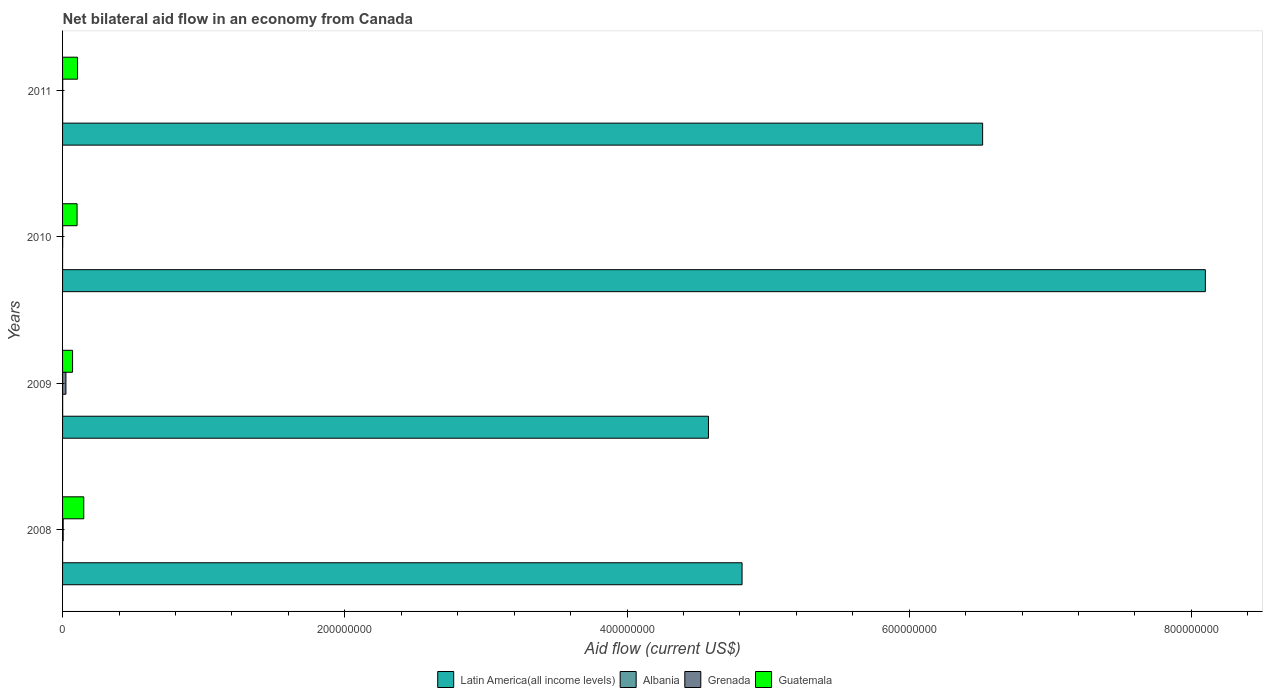How many different coloured bars are there?
Ensure brevity in your answer.  4. How many groups of bars are there?
Your answer should be compact. 4. Are the number of bars per tick equal to the number of legend labels?
Offer a very short reply. Yes. How many bars are there on the 1st tick from the top?
Your answer should be compact. 4. What is the label of the 3rd group of bars from the top?
Offer a terse response. 2009. Across all years, what is the maximum net bilateral aid flow in Grenada?
Ensure brevity in your answer.  2.38e+06. Across all years, what is the minimum net bilateral aid flow in Grenada?
Give a very brief answer. 9.00e+04. In which year was the net bilateral aid flow in Guatemala minimum?
Your answer should be compact. 2009. What is the total net bilateral aid flow in Guatemala in the graph?
Your answer should be compact. 4.30e+07. What is the difference between the net bilateral aid flow in Latin America(all income levels) in 2010 and the net bilateral aid flow in Grenada in 2009?
Your answer should be very brief. 8.07e+08. What is the average net bilateral aid flow in Albania per year?
Offer a very short reply. 4.50e+04. In the year 2011, what is the difference between the net bilateral aid flow in Albania and net bilateral aid flow in Guatemala?
Your response must be concise. -1.05e+07. What is the ratio of the net bilateral aid flow in Latin America(all income levels) in 2008 to that in 2011?
Keep it short and to the point. 0.74. Is the net bilateral aid flow in Latin America(all income levels) in 2009 less than that in 2011?
Provide a succinct answer. Yes. What is the difference between the highest and the second highest net bilateral aid flow in Albania?
Provide a short and direct response. 10000. What is the difference between the highest and the lowest net bilateral aid flow in Latin America(all income levels)?
Your response must be concise. 3.52e+08. In how many years, is the net bilateral aid flow in Guatemala greater than the average net bilateral aid flow in Guatemala taken over all years?
Offer a terse response. 1. Is the sum of the net bilateral aid flow in Albania in 2009 and 2010 greater than the maximum net bilateral aid flow in Latin America(all income levels) across all years?
Provide a succinct answer. No. Is it the case that in every year, the sum of the net bilateral aid flow in Grenada and net bilateral aid flow in Albania is greater than the sum of net bilateral aid flow in Guatemala and net bilateral aid flow in Latin America(all income levels)?
Your response must be concise. No. What does the 4th bar from the top in 2008 represents?
Make the answer very short. Latin America(all income levels). What does the 2nd bar from the bottom in 2011 represents?
Offer a very short reply. Albania. Is it the case that in every year, the sum of the net bilateral aid flow in Latin America(all income levels) and net bilateral aid flow in Albania is greater than the net bilateral aid flow in Grenada?
Ensure brevity in your answer.  Yes. How many bars are there?
Keep it short and to the point. 16. How many years are there in the graph?
Offer a very short reply. 4. What is the difference between two consecutive major ticks on the X-axis?
Your response must be concise. 2.00e+08. Are the values on the major ticks of X-axis written in scientific E-notation?
Keep it short and to the point. No. Does the graph contain any zero values?
Provide a succinct answer. No. Does the graph contain grids?
Ensure brevity in your answer.  No. Where does the legend appear in the graph?
Your response must be concise. Bottom center. How are the legend labels stacked?
Offer a very short reply. Horizontal. What is the title of the graph?
Give a very brief answer. Net bilateral aid flow in an economy from Canada. Does "Grenada" appear as one of the legend labels in the graph?
Keep it short and to the point. Yes. What is the label or title of the Y-axis?
Give a very brief answer. Years. What is the Aid flow (current US$) in Latin America(all income levels) in 2008?
Ensure brevity in your answer.  4.82e+08. What is the Aid flow (current US$) of Grenada in 2008?
Provide a succinct answer. 4.40e+05. What is the Aid flow (current US$) in Guatemala in 2008?
Provide a short and direct response. 1.50e+07. What is the Aid flow (current US$) in Latin America(all income levels) in 2009?
Make the answer very short. 4.58e+08. What is the Aid flow (current US$) of Grenada in 2009?
Ensure brevity in your answer.  2.38e+06. What is the Aid flow (current US$) in Guatemala in 2009?
Your answer should be very brief. 7.08e+06. What is the Aid flow (current US$) of Latin America(all income levels) in 2010?
Keep it short and to the point. 8.10e+08. What is the Aid flow (current US$) in Guatemala in 2010?
Provide a short and direct response. 1.03e+07. What is the Aid flow (current US$) of Latin America(all income levels) in 2011?
Provide a short and direct response. 6.52e+08. What is the Aid flow (current US$) in Albania in 2011?
Ensure brevity in your answer.  7.00e+04. What is the Aid flow (current US$) of Guatemala in 2011?
Your answer should be compact. 1.06e+07. Across all years, what is the maximum Aid flow (current US$) in Latin America(all income levels)?
Keep it short and to the point. 8.10e+08. Across all years, what is the maximum Aid flow (current US$) in Albania?
Make the answer very short. 7.00e+04. Across all years, what is the maximum Aid flow (current US$) in Grenada?
Keep it short and to the point. 2.38e+06. Across all years, what is the maximum Aid flow (current US$) in Guatemala?
Ensure brevity in your answer.  1.50e+07. Across all years, what is the minimum Aid flow (current US$) of Latin America(all income levels)?
Offer a terse response. 4.58e+08. Across all years, what is the minimum Aid flow (current US$) of Grenada?
Your response must be concise. 9.00e+04. Across all years, what is the minimum Aid flow (current US$) of Guatemala?
Keep it short and to the point. 7.08e+06. What is the total Aid flow (current US$) in Latin America(all income levels) in the graph?
Offer a terse response. 2.40e+09. What is the total Aid flow (current US$) of Grenada in the graph?
Offer a terse response. 3.02e+06. What is the total Aid flow (current US$) in Guatemala in the graph?
Your response must be concise. 4.30e+07. What is the difference between the Aid flow (current US$) in Latin America(all income levels) in 2008 and that in 2009?
Provide a succinct answer. 2.38e+07. What is the difference between the Aid flow (current US$) in Grenada in 2008 and that in 2009?
Ensure brevity in your answer.  -1.94e+06. What is the difference between the Aid flow (current US$) in Guatemala in 2008 and that in 2009?
Your response must be concise. 7.94e+06. What is the difference between the Aid flow (current US$) in Latin America(all income levels) in 2008 and that in 2010?
Give a very brief answer. -3.28e+08. What is the difference between the Aid flow (current US$) in Grenada in 2008 and that in 2010?
Give a very brief answer. 3.50e+05. What is the difference between the Aid flow (current US$) in Guatemala in 2008 and that in 2010?
Your answer should be very brief. 4.75e+06. What is the difference between the Aid flow (current US$) of Latin America(all income levels) in 2008 and that in 2011?
Provide a succinct answer. -1.70e+08. What is the difference between the Aid flow (current US$) in Grenada in 2008 and that in 2011?
Give a very brief answer. 3.30e+05. What is the difference between the Aid flow (current US$) of Guatemala in 2008 and that in 2011?
Ensure brevity in your answer.  4.43e+06. What is the difference between the Aid flow (current US$) of Latin America(all income levels) in 2009 and that in 2010?
Keep it short and to the point. -3.52e+08. What is the difference between the Aid flow (current US$) in Grenada in 2009 and that in 2010?
Your answer should be compact. 2.29e+06. What is the difference between the Aid flow (current US$) in Guatemala in 2009 and that in 2010?
Your answer should be very brief. -3.19e+06. What is the difference between the Aid flow (current US$) of Latin America(all income levels) in 2009 and that in 2011?
Offer a terse response. -1.94e+08. What is the difference between the Aid flow (current US$) in Albania in 2009 and that in 2011?
Your response must be concise. -10000. What is the difference between the Aid flow (current US$) of Grenada in 2009 and that in 2011?
Provide a short and direct response. 2.27e+06. What is the difference between the Aid flow (current US$) in Guatemala in 2009 and that in 2011?
Offer a terse response. -3.51e+06. What is the difference between the Aid flow (current US$) of Latin America(all income levels) in 2010 and that in 2011?
Ensure brevity in your answer.  1.58e+08. What is the difference between the Aid flow (current US$) in Guatemala in 2010 and that in 2011?
Keep it short and to the point. -3.20e+05. What is the difference between the Aid flow (current US$) in Latin America(all income levels) in 2008 and the Aid flow (current US$) in Albania in 2009?
Your answer should be very brief. 4.81e+08. What is the difference between the Aid flow (current US$) in Latin America(all income levels) in 2008 and the Aid flow (current US$) in Grenada in 2009?
Offer a terse response. 4.79e+08. What is the difference between the Aid flow (current US$) in Latin America(all income levels) in 2008 and the Aid flow (current US$) in Guatemala in 2009?
Your answer should be compact. 4.74e+08. What is the difference between the Aid flow (current US$) in Albania in 2008 and the Aid flow (current US$) in Grenada in 2009?
Your response must be concise. -2.34e+06. What is the difference between the Aid flow (current US$) of Albania in 2008 and the Aid flow (current US$) of Guatemala in 2009?
Your response must be concise. -7.04e+06. What is the difference between the Aid flow (current US$) in Grenada in 2008 and the Aid flow (current US$) in Guatemala in 2009?
Offer a terse response. -6.64e+06. What is the difference between the Aid flow (current US$) of Latin America(all income levels) in 2008 and the Aid flow (current US$) of Albania in 2010?
Ensure brevity in your answer.  4.82e+08. What is the difference between the Aid flow (current US$) in Latin America(all income levels) in 2008 and the Aid flow (current US$) in Grenada in 2010?
Provide a succinct answer. 4.81e+08. What is the difference between the Aid flow (current US$) in Latin America(all income levels) in 2008 and the Aid flow (current US$) in Guatemala in 2010?
Your answer should be very brief. 4.71e+08. What is the difference between the Aid flow (current US$) of Albania in 2008 and the Aid flow (current US$) of Guatemala in 2010?
Your response must be concise. -1.02e+07. What is the difference between the Aid flow (current US$) of Grenada in 2008 and the Aid flow (current US$) of Guatemala in 2010?
Ensure brevity in your answer.  -9.83e+06. What is the difference between the Aid flow (current US$) of Latin America(all income levels) in 2008 and the Aid flow (current US$) of Albania in 2011?
Give a very brief answer. 4.81e+08. What is the difference between the Aid flow (current US$) in Latin America(all income levels) in 2008 and the Aid flow (current US$) in Grenada in 2011?
Give a very brief answer. 4.81e+08. What is the difference between the Aid flow (current US$) of Latin America(all income levels) in 2008 and the Aid flow (current US$) of Guatemala in 2011?
Offer a very short reply. 4.71e+08. What is the difference between the Aid flow (current US$) of Albania in 2008 and the Aid flow (current US$) of Grenada in 2011?
Provide a succinct answer. -7.00e+04. What is the difference between the Aid flow (current US$) in Albania in 2008 and the Aid flow (current US$) in Guatemala in 2011?
Offer a terse response. -1.06e+07. What is the difference between the Aid flow (current US$) in Grenada in 2008 and the Aid flow (current US$) in Guatemala in 2011?
Offer a terse response. -1.02e+07. What is the difference between the Aid flow (current US$) of Latin America(all income levels) in 2009 and the Aid flow (current US$) of Albania in 2010?
Give a very brief answer. 4.58e+08. What is the difference between the Aid flow (current US$) of Latin America(all income levels) in 2009 and the Aid flow (current US$) of Grenada in 2010?
Make the answer very short. 4.58e+08. What is the difference between the Aid flow (current US$) of Latin America(all income levels) in 2009 and the Aid flow (current US$) of Guatemala in 2010?
Make the answer very short. 4.47e+08. What is the difference between the Aid flow (current US$) of Albania in 2009 and the Aid flow (current US$) of Grenada in 2010?
Make the answer very short. -3.00e+04. What is the difference between the Aid flow (current US$) of Albania in 2009 and the Aid flow (current US$) of Guatemala in 2010?
Your answer should be compact. -1.02e+07. What is the difference between the Aid flow (current US$) of Grenada in 2009 and the Aid flow (current US$) of Guatemala in 2010?
Offer a terse response. -7.89e+06. What is the difference between the Aid flow (current US$) in Latin America(all income levels) in 2009 and the Aid flow (current US$) in Albania in 2011?
Make the answer very short. 4.58e+08. What is the difference between the Aid flow (current US$) of Latin America(all income levels) in 2009 and the Aid flow (current US$) of Grenada in 2011?
Make the answer very short. 4.58e+08. What is the difference between the Aid flow (current US$) of Latin America(all income levels) in 2009 and the Aid flow (current US$) of Guatemala in 2011?
Offer a very short reply. 4.47e+08. What is the difference between the Aid flow (current US$) in Albania in 2009 and the Aid flow (current US$) in Grenada in 2011?
Give a very brief answer. -5.00e+04. What is the difference between the Aid flow (current US$) of Albania in 2009 and the Aid flow (current US$) of Guatemala in 2011?
Provide a succinct answer. -1.05e+07. What is the difference between the Aid flow (current US$) of Grenada in 2009 and the Aid flow (current US$) of Guatemala in 2011?
Offer a terse response. -8.21e+06. What is the difference between the Aid flow (current US$) of Latin America(all income levels) in 2010 and the Aid flow (current US$) of Albania in 2011?
Your answer should be very brief. 8.10e+08. What is the difference between the Aid flow (current US$) of Latin America(all income levels) in 2010 and the Aid flow (current US$) of Grenada in 2011?
Your answer should be compact. 8.10e+08. What is the difference between the Aid flow (current US$) of Latin America(all income levels) in 2010 and the Aid flow (current US$) of Guatemala in 2011?
Your response must be concise. 7.99e+08. What is the difference between the Aid flow (current US$) in Albania in 2010 and the Aid flow (current US$) in Guatemala in 2011?
Provide a short and direct response. -1.06e+07. What is the difference between the Aid flow (current US$) in Grenada in 2010 and the Aid flow (current US$) in Guatemala in 2011?
Give a very brief answer. -1.05e+07. What is the average Aid flow (current US$) of Latin America(all income levels) per year?
Offer a terse response. 6.00e+08. What is the average Aid flow (current US$) in Albania per year?
Offer a terse response. 4.50e+04. What is the average Aid flow (current US$) of Grenada per year?
Keep it short and to the point. 7.55e+05. What is the average Aid flow (current US$) of Guatemala per year?
Your response must be concise. 1.07e+07. In the year 2008, what is the difference between the Aid flow (current US$) of Latin America(all income levels) and Aid flow (current US$) of Albania?
Your response must be concise. 4.82e+08. In the year 2008, what is the difference between the Aid flow (current US$) in Latin America(all income levels) and Aid flow (current US$) in Grenada?
Your answer should be very brief. 4.81e+08. In the year 2008, what is the difference between the Aid flow (current US$) of Latin America(all income levels) and Aid flow (current US$) of Guatemala?
Provide a succinct answer. 4.67e+08. In the year 2008, what is the difference between the Aid flow (current US$) in Albania and Aid flow (current US$) in Grenada?
Provide a succinct answer. -4.00e+05. In the year 2008, what is the difference between the Aid flow (current US$) of Albania and Aid flow (current US$) of Guatemala?
Offer a terse response. -1.50e+07. In the year 2008, what is the difference between the Aid flow (current US$) in Grenada and Aid flow (current US$) in Guatemala?
Provide a short and direct response. -1.46e+07. In the year 2009, what is the difference between the Aid flow (current US$) of Latin America(all income levels) and Aid flow (current US$) of Albania?
Your answer should be very brief. 4.58e+08. In the year 2009, what is the difference between the Aid flow (current US$) of Latin America(all income levels) and Aid flow (current US$) of Grenada?
Your answer should be compact. 4.55e+08. In the year 2009, what is the difference between the Aid flow (current US$) in Latin America(all income levels) and Aid flow (current US$) in Guatemala?
Your response must be concise. 4.51e+08. In the year 2009, what is the difference between the Aid flow (current US$) of Albania and Aid flow (current US$) of Grenada?
Keep it short and to the point. -2.32e+06. In the year 2009, what is the difference between the Aid flow (current US$) in Albania and Aid flow (current US$) in Guatemala?
Provide a short and direct response. -7.02e+06. In the year 2009, what is the difference between the Aid flow (current US$) in Grenada and Aid flow (current US$) in Guatemala?
Make the answer very short. -4.70e+06. In the year 2010, what is the difference between the Aid flow (current US$) in Latin America(all income levels) and Aid flow (current US$) in Albania?
Make the answer very short. 8.10e+08. In the year 2010, what is the difference between the Aid flow (current US$) in Latin America(all income levels) and Aid flow (current US$) in Grenada?
Ensure brevity in your answer.  8.10e+08. In the year 2010, what is the difference between the Aid flow (current US$) in Latin America(all income levels) and Aid flow (current US$) in Guatemala?
Offer a terse response. 8.00e+08. In the year 2010, what is the difference between the Aid flow (current US$) in Albania and Aid flow (current US$) in Grenada?
Offer a terse response. -8.00e+04. In the year 2010, what is the difference between the Aid flow (current US$) of Albania and Aid flow (current US$) of Guatemala?
Make the answer very short. -1.03e+07. In the year 2010, what is the difference between the Aid flow (current US$) of Grenada and Aid flow (current US$) of Guatemala?
Keep it short and to the point. -1.02e+07. In the year 2011, what is the difference between the Aid flow (current US$) in Latin America(all income levels) and Aid flow (current US$) in Albania?
Your answer should be very brief. 6.52e+08. In the year 2011, what is the difference between the Aid flow (current US$) in Latin America(all income levels) and Aid flow (current US$) in Grenada?
Keep it short and to the point. 6.52e+08. In the year 2011, what is the difference between the Aid flow (current US$) of Latin America(all income levels) and Aid flow (current US$) of Guatemala?
Provide a short and direct response. 6.41e+08. In the year 2011, what is the difference between the Aid flow (current US$) of Albania and Aid flow (current US$) of Guatemala?
Give a very brief answer. -1.05e+07. In the year 2011, what is the difference between the Aid flow (current US$) of Grenada and Aid flow (current US$) of Guatemala?
Offer a very short reply. -1.05e+07. What is the ratio of the Aid flow (current US$) of Latin America(all income levels) in 2008 to that in 2009?
Offer a very short reply. 1.05. What is the ratio of the Aid flow (current US$) of Grenada in 2008 to that in 2009?
Ensure brevity in your answer.  0.18. What is the ratio of the Aid flow (current US$) of Guatemala in 2008 to that in 2009?
Keep it short and to the point. 2.12. What is the ratio of the Aid flow (current US$) of Latin America(all income levels) in 2008 to that in 2010?
Your response must be concise. 0.59. What is the ratio of the Aid flow (current US$) of Albania in 2008 to that in 2010?
Provide a succinct answer. 4. What is the ratio of the Aid flow (current US$) in Grenada in 2008 to that in 2010?
Provide a short and direct response. 4.89. What is the ratio of the Aid flow (current US$) in Guatemala in 2008 to that in 2010?
Provide a short and direct response. 1.46. What is the ratio of the Aid flow (current US$) of Latin America(all income levels) in 2008 to that in 2011?
Provide a short and direct response. 0.74. What is the ratio of the Aid flow (current US$) in Albania in 2008 to that in 2011?
Ensure brevity in your answer.  0.57. What is the ratio of the Aid flow (current US$) in Guatemala in 2008 to that in 2011?
Give a very brief answer. 1.42. What is the ratio of the Aid flow (current US$) in Latin America(all income levels) in 2009 to that in 2010?
Give a very brief answer. 0.57. What is the ratio of the Aid flow (current US$) in Albania in 2009 to that in 2010?
Ensure brevity in your answer.  6. What is the ratio of the Aid flow (current US$) of Grenada in 2009 to that in 2010?
Offer a terse response. 26.44. What is the ratio of the Aid flow (current US$) of Guatemala in 2009 to that in 2010?
Your response must be concise. 0.69. What is the ratio of the Aid flow (current US$) in Latin America(all income levels) in 2009 to that in 2011?
Give a very brief answer. 0.7. What is the ratio of the Aid flow (current US$) of Grenada in 2009 to that in 2011?
Provide a succinct answer. 21.64. What is the ratio of the Aid flow (current US$) in Guatemala in 2009 to that in 2011?
Provide a short and direct response. 0.67. What is the ratio of the Aid flow (current US$) of Latin America(all income levels) in 2010 to that in 2011?
Offer a very short reply. 1.24. What is the ratio of the Aid flow (current US$) in Albania in 2010 to that in 2011?
Offer a terse response. 0.14. What is the ratio of the Aid flow (current US$) of Grenada in 2010 to that in 2011?
Your answer should be compact. 0.82. What is the ratio of the Aid flow (current US$) of Guatemala in 2010 to that in 2011?
Make the answer very short. 0.97. What is the difference between the highest and the second highest Aid flow (current US$) in Latin America(all income levels)?
Your answer should be compact. 1.58e+08. What is the difference between the highest and the second highest Aid flow (current US$) of Albania?
Make the answer very short. 10000. What is the difference between the highest and the second highest Aid flow (current US$) in Grenada?
Provide a short and direct response. 1.94e+06. What is the difference between the highest and the second highest Aid flow (current US$) in Guatemala?
Give a very brief answer. 4.43e+06. What is the difference between the highest and the lowest Aid flow (current US$) in Latin America(all income levels)?
Ensure brevity in your answer.  3.52e+08. What is the difference between the highest and the lowest Aid flow (current US$) of Grenada?
Make the answer very short. 2.29e+06. What is the difference between the highest and the lowest Aid flow (current US$) in Guatemala?
Make the answer very short. 7.94e+06. 